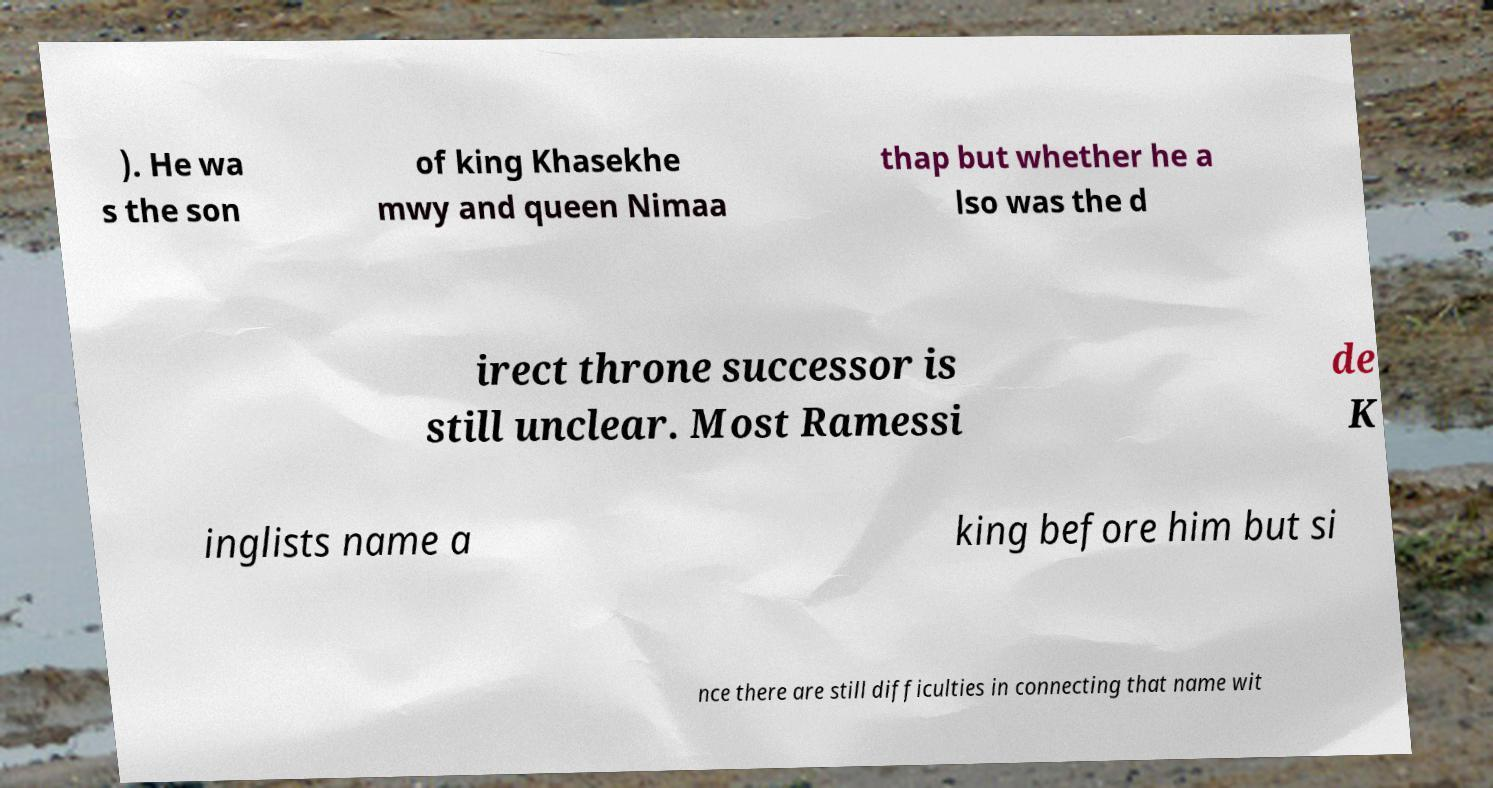Please identify and transcribe the text found in this image. ). He wa s the son of king Khasekhe mwy and queen Nimaa thap but whether he a lso was the d irect throne successor is still unclear. Most Ramessi de K inglists name a king before him but si nce there are still difficulties in connecting that name wit 